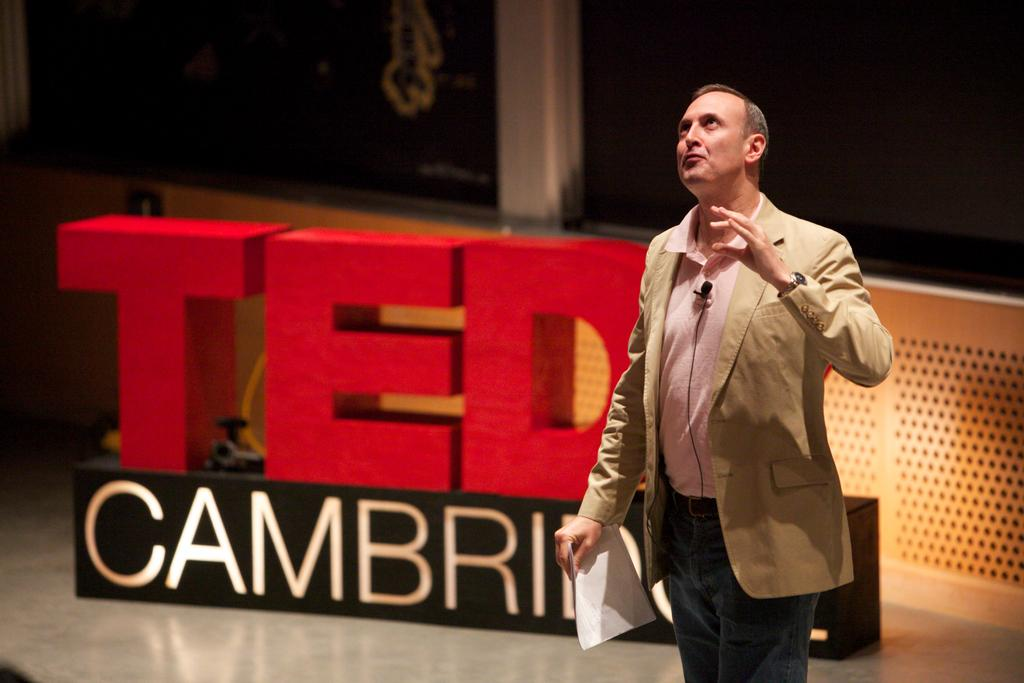What is the person in the image doing? The person is standing in the image and holding a paper. What else can be seen in the image besides the person? There is a display board in the image. What type of pets can be seen on the slope in the image? There is no slope or pets present in the image. 